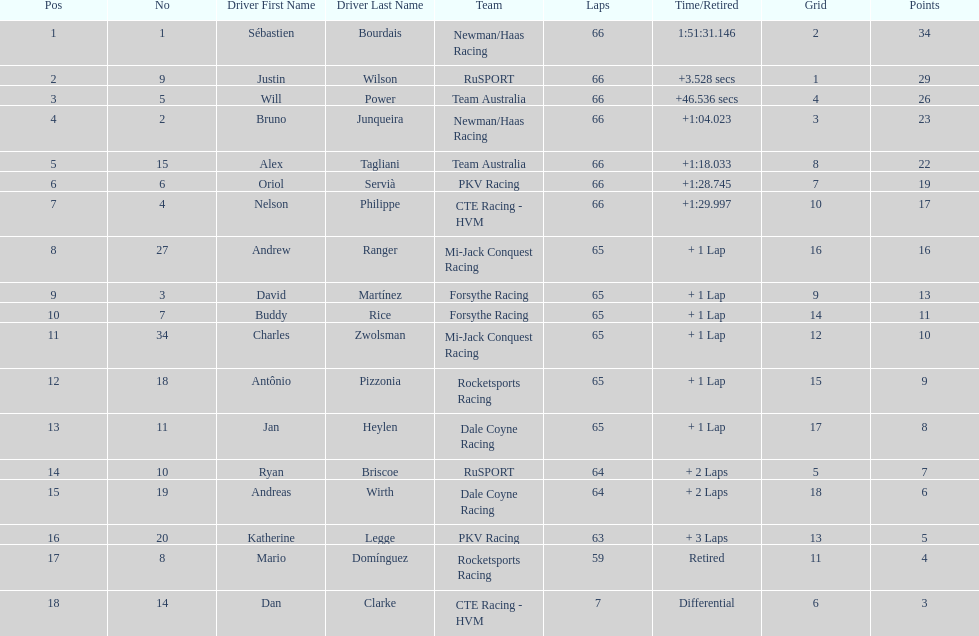Which driver has the same number as his/her position? Sébastien Bourdais. 